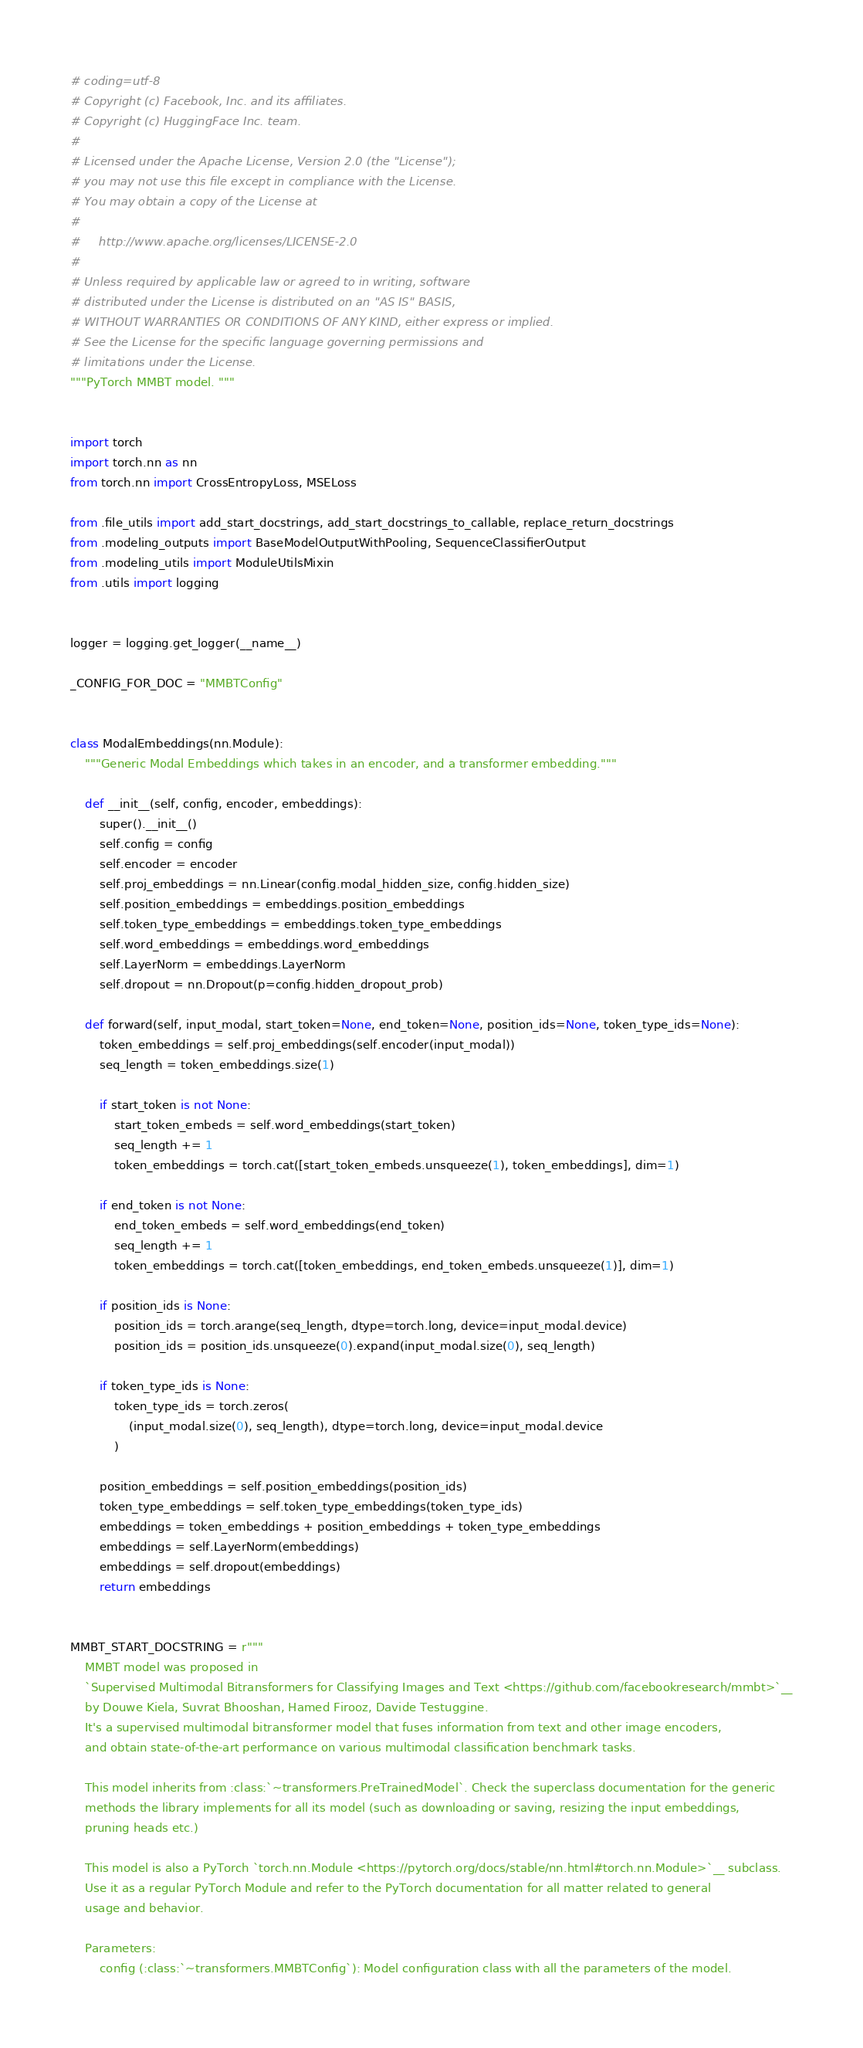Convert code to text. <code><loc_0><loc_0><loc_500><loc_500><_Python_># coding=utf-8
# Copyright (c) Facebook, Inc. and its affiliates.
# Copyright (c) HuggingFace Inc. team.
#
# Licensed under the Apache License, Version 2.0 (the "License");
# you may not use this file except in compliance with the License.
# You may obtain a copy of the License at
#
#     http://www.apache.org/licenses/LICENSE-2.0
#
# Unless required by applicable law or agreed to in writing, software
# distributed under the License is distributed on an "AS IS" BASIS,
# WITHOUT WARRANTIES OR CONDITIONS OF ANY KIND, either express or implied.
# See the License for the specific language governing permissions and
# limitations under the License.
"""PyTorch MMBT model. """


import torch
import torch.nn as nn
from torch.nn import CrossEntropyLoss, MSELoss

from .file_utils import add_start_docstrings, add_start_docstrings_to_callable, replace_return_docstrings
from .modeling_outputs import BaseModelOutputWithPooling, SequenceClassifierOutput
from .modeling_utils import ModuleUtilsMixin
from .utils import logging


logger = logging.get_logger(__name__)

_CONFIG_FOR_DOC = "MMBTConfig"


class ModalEmbeddings(nn.Module):
    """Generic Modal Embeddings which takes in an encoder, and a transformer embedding."""

    def __init__(self, config, encoder, embeddings):
        super().__init__()
        self.config = config
        self.encoder = encoder
        self.proj_embeddings = nn.Linear(config.modal_hidden_size, config.hidden_size)
        self.position_embeddings = embeddings.position_embeddings
        self.token_type_embeddings = embeddings.token_type_embeddings
        self.word_embeddings = embeddings.word_embeddings
        self.LayerNorm = embeddings.LayerNorm
        self.dropout = nn.Dropout(p=config.hidden_dropout_prob)

    def forward(self, input_modal, start_token=None, end_token=None, position_ids=None, token_type_ids=None):
        token_embeddings = self.proj_embeddings(self.encoder(input_modal))
        seq_length = token_embeddings.size(1)

        if start_token is not None:
            start_token_embeds = self.word_embeddings(start_token)
            seq_length += 1
            token_embeddings = torch.cat([start_token_embeds.unsqueeze(1), token_embeddings], dim=1)

        if end_token is not None:
            end_token_embeds = self.word_embeddings(end_token)
            seq_length += 1
            token_embeddings = torch.cat([token_embeddings, end_token_embeds.unsqueeze(1)], dim=1)

        if position_ids is None:
            position_ids = torch.arange(seq_length, dtype=torch.long, device=input_modal.device)
            position_ids = position_ids.unsqueeze(0).expand(input_modal.size(0), seq_length)

        if token_type_ids is None:
            token_type_ids = torch.zeros(
                (input_modal.size(0), seq_length), dtype=torch.long, device=input_modal.device
            )

        position_embeddings = self.position_embeddings(position_ids)
        token_type_embeddings = self.token_type_embeddings(token_type_ids)
        embeddings = token_embeddings + position_embeddings + token_type_embeddings
        embeddings = self.LayerNorm(embeddings)
        embeddings = self.dropout(embeddings)
        return embeddings


MMBT_START_DOCSTRING = r"""
    MMBT model was proposed in
    `Supervised Multimodal Bitransformers for Classifying Images and Text <https://github.com/facebookresearch/mmbt>`__
    by Douwe Kiela, Suvrat Bhooshan, Hamed Firooz, Davide Testuggine.
    It's a supervised multimodal bitransformer model that fuses information from text and other image encoders,
    and obtain state-of-the-art performance on various multimodal classification benchmark tasks.

    This model inherits from :class:`~transformers.PreTrainedModel`. Check the superclass documentation for the generic
    methods the library implements for all its model (such as downloading or saving, resizing the input embeddings,
    pruning heads etc.)

    This model is also a PyTorch `torch.nn.Module <https://pytorch.org/docs/stable/nn.html#torch.nn.Module>`__ subclass.
    Use it as a regular PyTorch Module and refer to the PyTorch documentation for all matter related to general
    usage and behavior.

    Parameters:
        config (:class:`~transformers.MMBTConfig`): Model configuration class with all the parameters of the model.</code> 